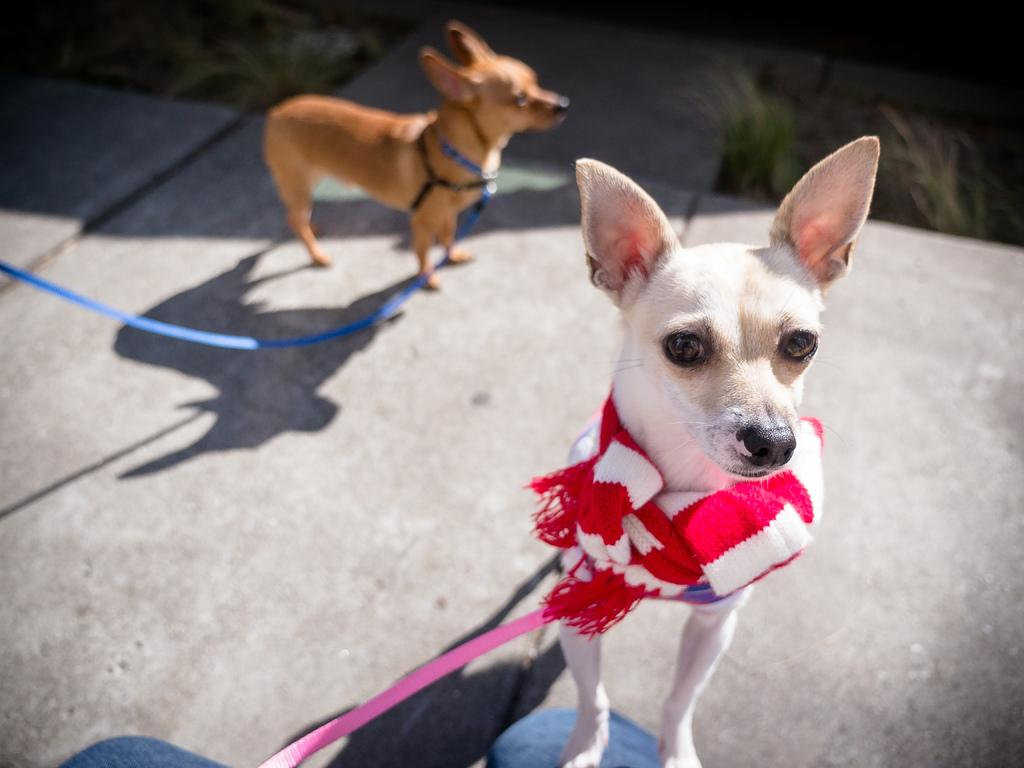How many dogs are present in the image? There are two dogs in the image. Where are the dogs located? The dogs are on the ground. Can you describe any additional features of the dogs? One of the dogs has a scarf around its neck. Is there any indication of a person's presence in the image? Yes, a person's leg is visible at the bottom of the image. What type of lunch is being served on the net in the image? There is no lunch or net present in the image; it features two dogs on the ground and a person's leg. 